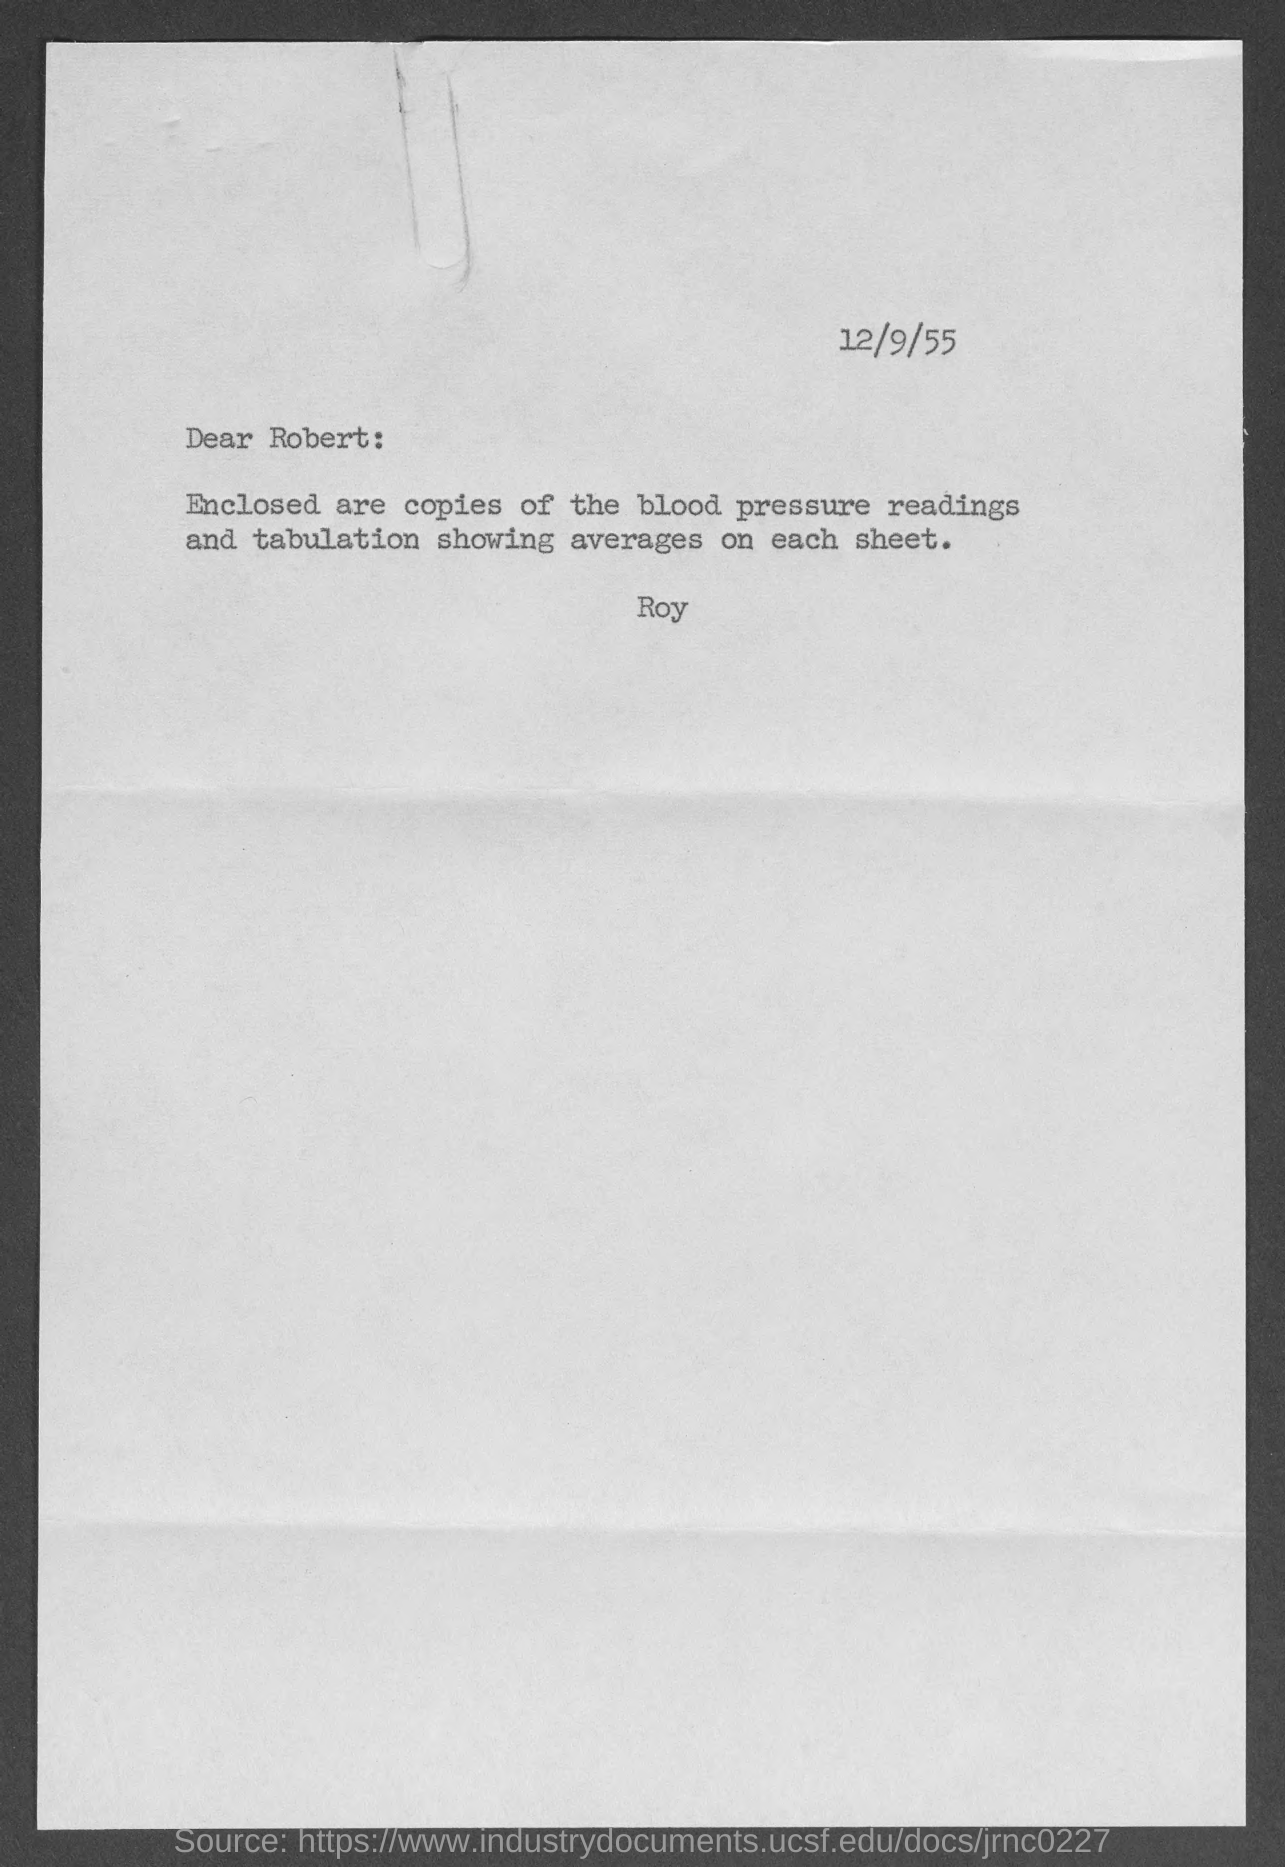Indicate a few pertinent items in this graphic. The date at the top of the page is December 9, 1955. 